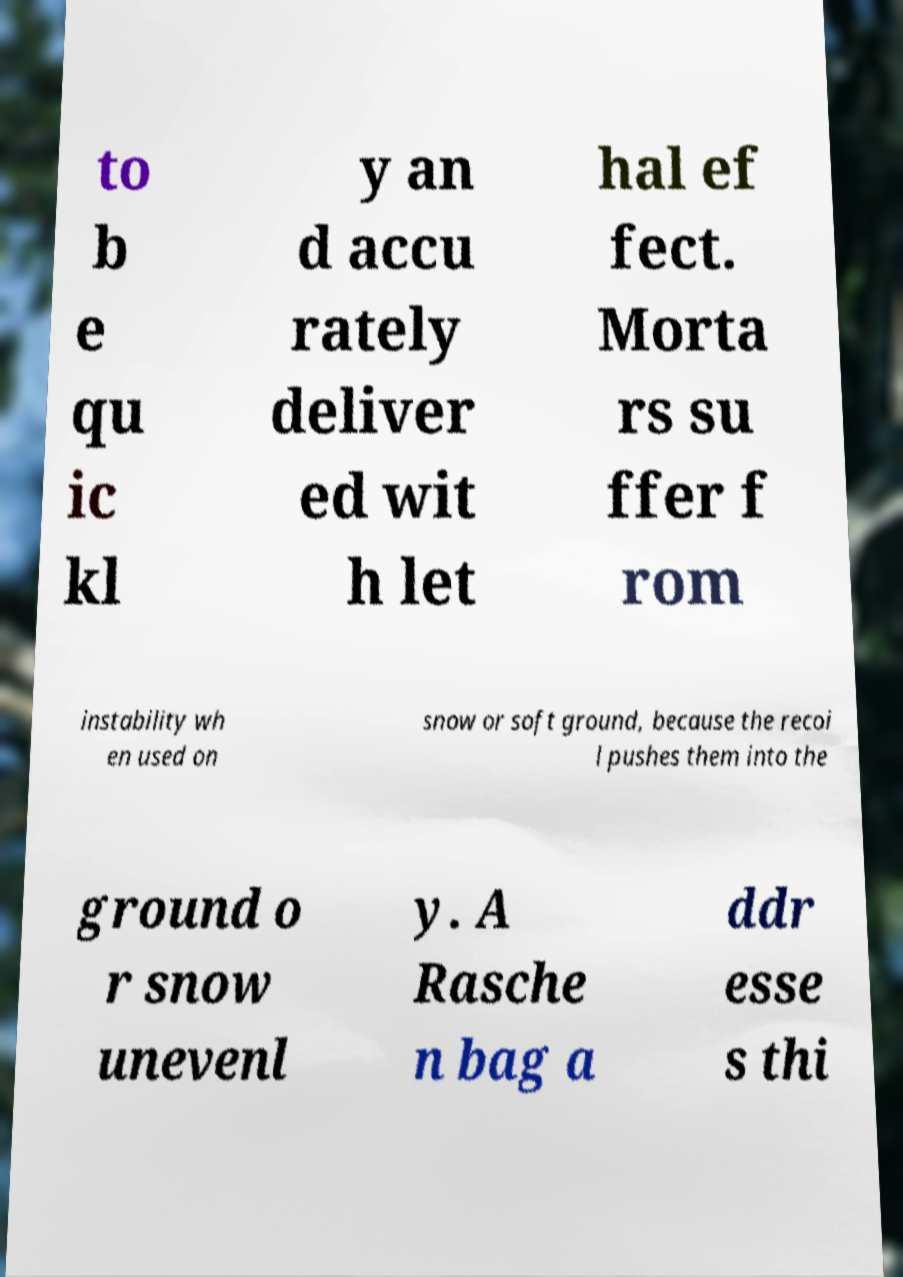Can you accurately transcribe the text from the provided image for me? to b e qu ic kl y an d accu rately deliver ed wit h let hal ef fect. Morta rs su ffer f rom instability wh en used on snow or soft ground, because the recoi l pushes them into the ground o r snow unevenl y. A Rasche n bag a ddr esse s thi 